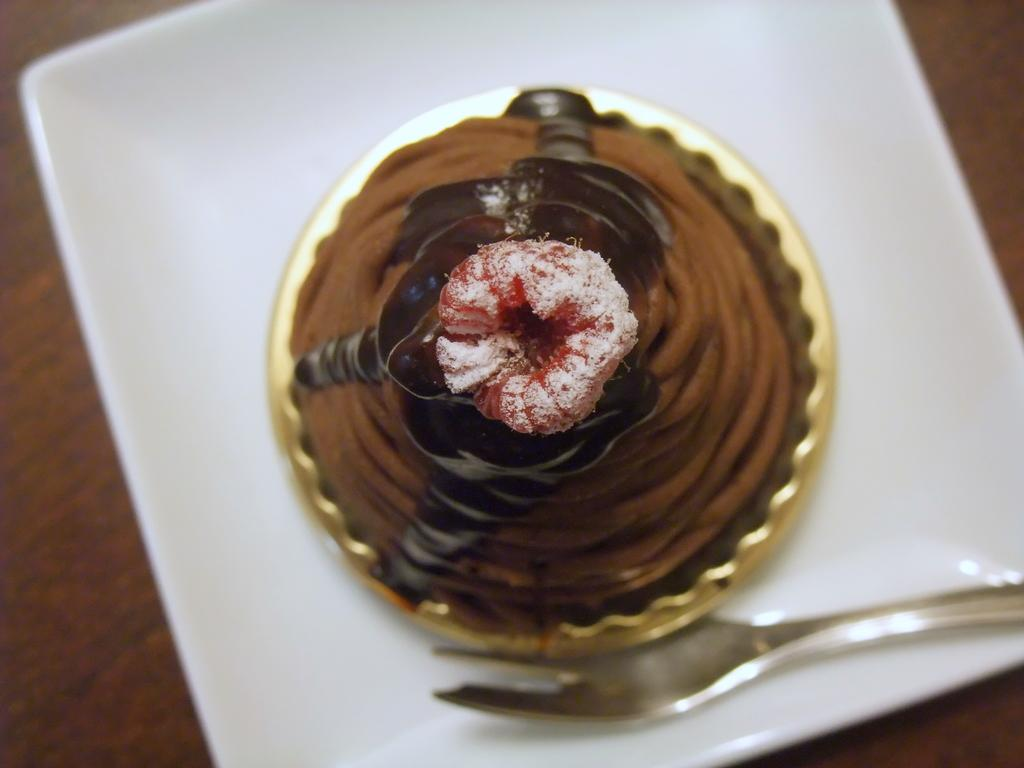What type of food item is visible in the image? There is a food item in the image, but the specific type is not mentioned in the facts. What utensil is present in the image? There is a fork in the image. Where is the fork located in relation to the food item? The fork is in a plate in the image. What is the plate resting on in the image? The plate is on a wooden platform in the image. What type of quiver can be seen in the image? There is no quiver present in the image. What sign is visible in the image? There is no sign visible in the image. What scent can be detected from the food item in the image? The facts provided do not mention any scent associated with the food item in the image. 